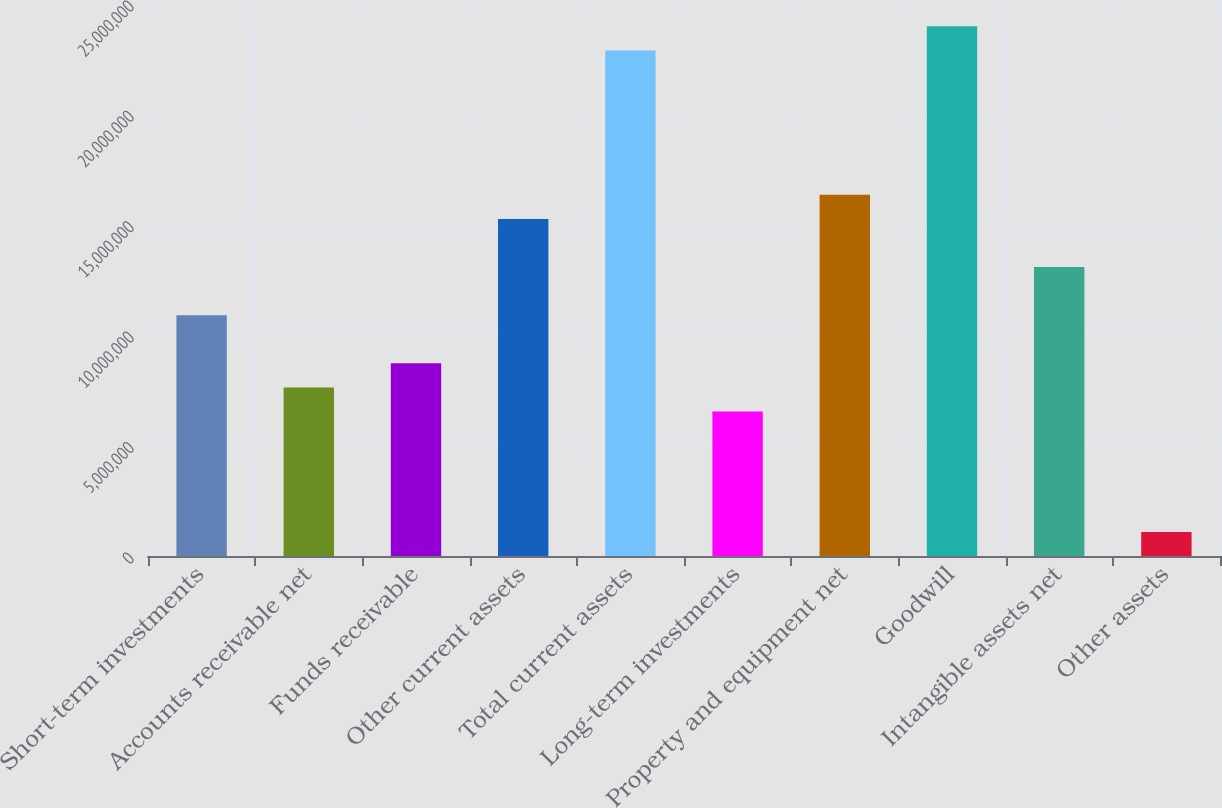Convert chart to OTSL. <chart><loc_0><loc_0><loc_500><loc_500><bar_chart><fcel>Short-term investments<fcel>Accounts receivable net<fcel>Funds receivable<fcel>Other current assets<fcel>Total current assets<fcel>Long-term investments<fcel>Property and equipment net<fcel>Goodwill<fcel>Intangible assets net<fcel>Other assets<nl><fcel>1.09046e+07<fcel>7.63367e+06<fcel>8.72399e+06<fcel>1.52659e+07<fcel>2.28982e+07<fcel>6.54335e+06<fcel>1.63562e+07<fcel>2.39885e+07<fcel>1.30853e+07<fcel>1.09175e+06<nl></chart> 